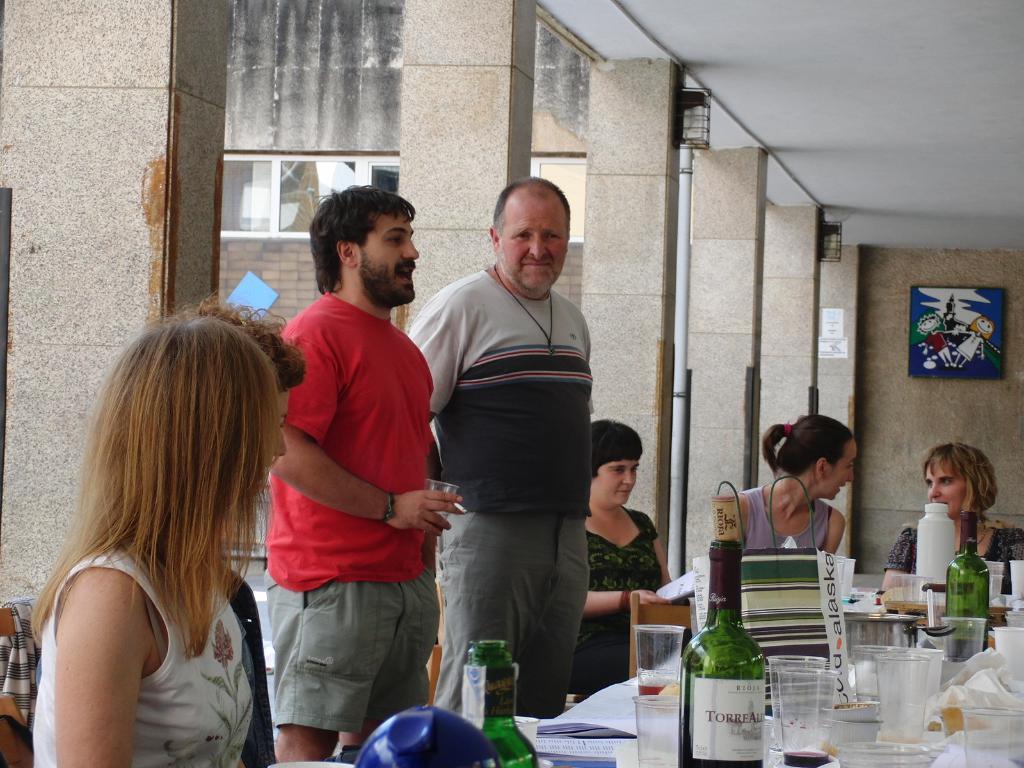How would you summarize this image in a sentence or two? in the picture we can see two people standing on floor and four women sitting on chair in front of them there was a table on the table we can find a glasses and bottles. 